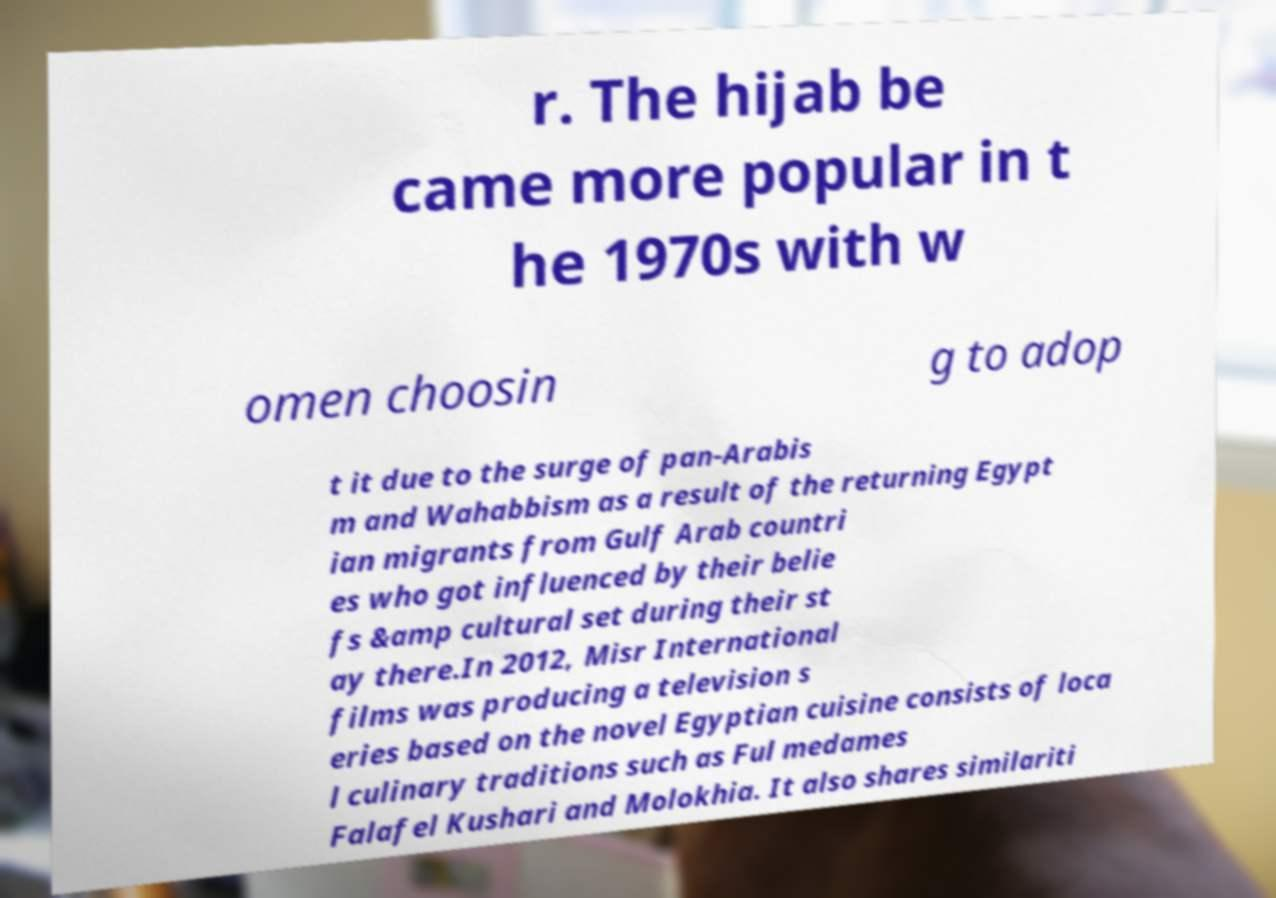Could you assist in decoding the text presented in this image and type it out clearly? r. The hijab be came more popular in t he 1970s with w omen choosin g to adop t it due to the surge of pan-Arabis m and Wahabbism as a result of the returning Egypt ian migrants from Gulf Arab countri es who got influenced by their belie fs &amp cultural set during their st ay there.In 2012, Misr International films was producing a television s eries based on the novel Egyptian cuisine consists of loca l culinary traditions such as Ful medames Falafel Kushari and Molokhia. It also shares similariti 